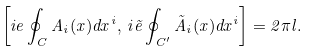Convert formula to latex. <formula><loc_0><loc_0><loc_500><loc_500>\left [ i e \oint _ { C } A _ { i } ( x ) d x ^ { i } , \, i \tilde { e } \oint _ { C ^ { \prime } } \tilde { A } _ { i } ( x ) d x ^ { i } \right ] = 2 \pi l .</formula> 